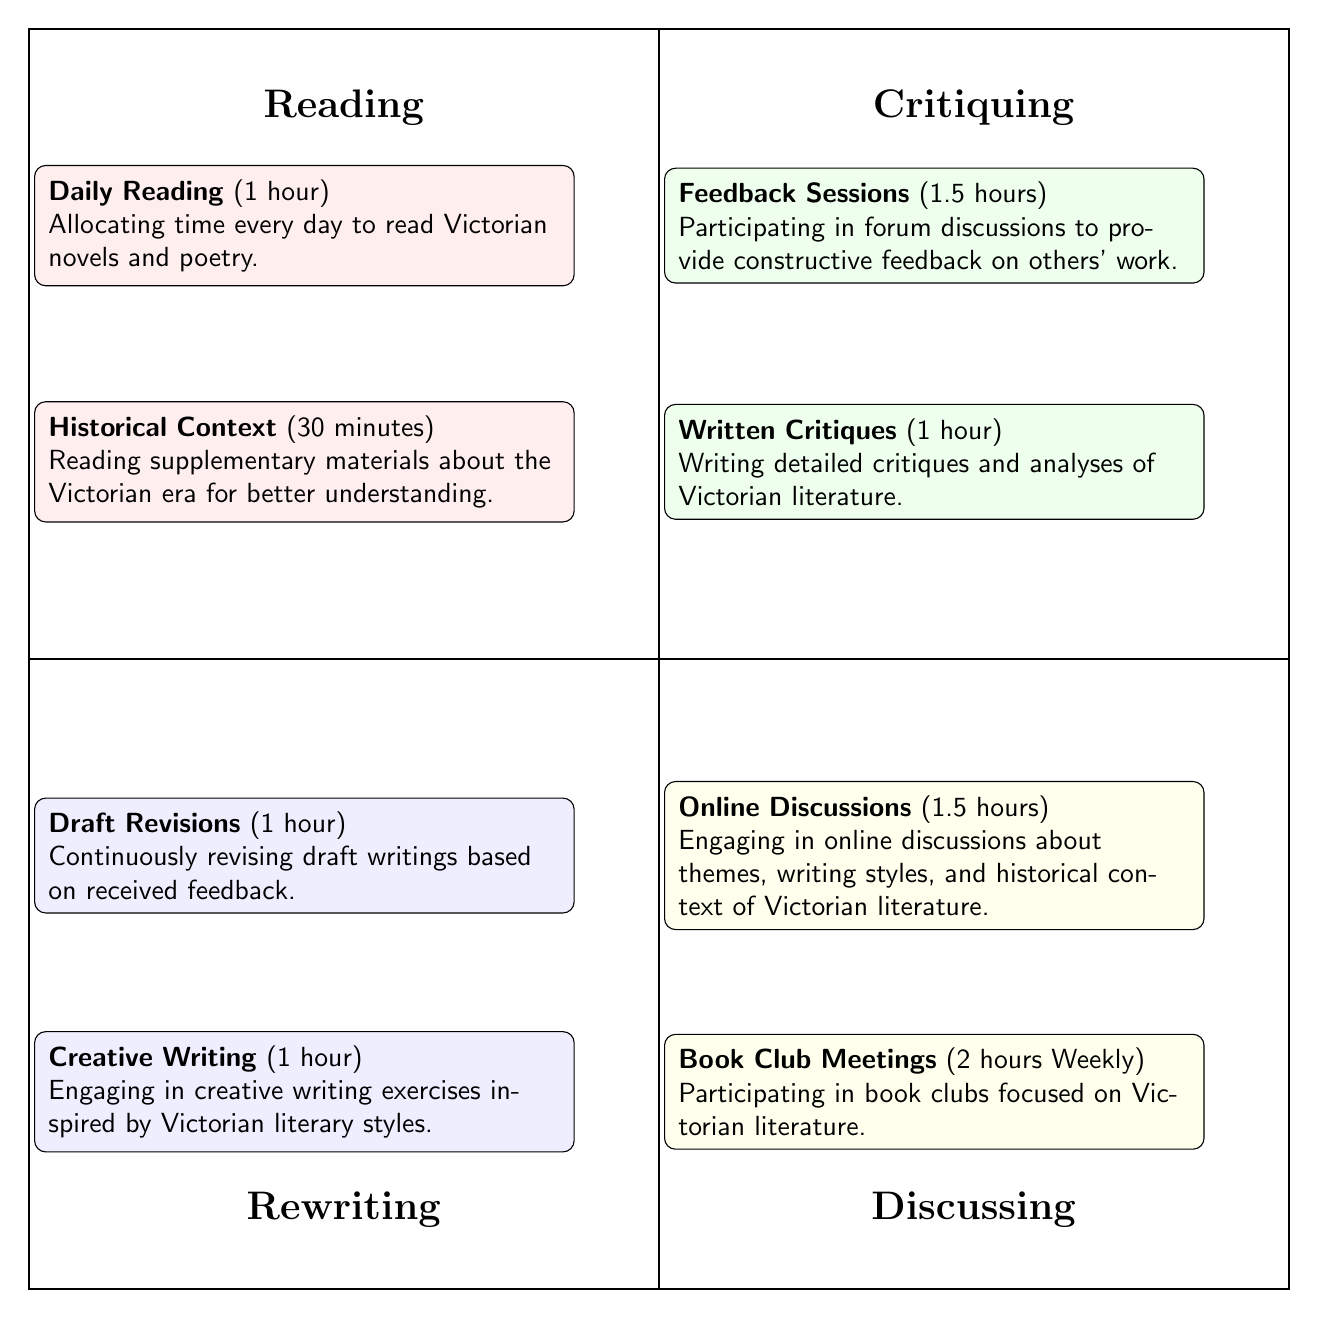What are the two activities in the "Reading" quadrant? The "Reading" quadrant contains two activities: "Daily Reading" and "Historical Context."
Answer: Daily Reading; Historical Context How much time is allocated for "Book Club Meetings"? "Book Club Meetings" in the "Discussing" quadrant is allocated 2 hours weekly.
Answer: 2 hours (Weekly) What is the total target time for "Critiquing" activities? The "Critiquing" quadrant includes "Feedback Sessions" (1.5 hours) and "Written Critiques" (1 hour), adding up to a total of 2.5 hours.
Answer: 2.5 hours How many activities are listed under the "Rewriting" quadrant? The "Rewriting" quadrant has two activities: "Draft Revisions" and "Creative Writing."
Answer: 2 activities Which quadrant has the longest individual activity time? The "Book Club Meetings" activity in the "Discussing" quadrant takes the longest at 2 hours weekly.
Answer: 2 hours (Weekly) What is the cumulative time allocated for "Discussing" activities? The "Discussing" quadrant has "Online Discussions" (1.5 hours) and "Book Club Meetings" (2 hours weekly), resulting in a total of 3.5 hours.
Answer: 3.5 hours Which quadrant has an activity focused on improving writing skills? The "Rewriting" quadrant includes "Draft Revisions" and "Creative Writing," both focused on improving writing skills.
Answer: Rewriting What is the shortest activity time among all listed activities? The "Historical Context" activity in the "Reading" quadrant is the shortest, taking 30 minutes.
Answer: 30 minutes How are the quadrants arranged in the diagram? The quadrants are arranged as follows: "Reading" (top left), "Critiquing" (top right), "Rewriting" (bottom left), and "Discussing" (bottom right).
Answer: Quadrants arranged: Reading, Critiquing, Rewriting, Discussing 